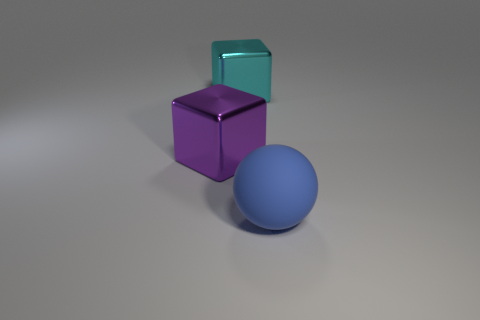Is there any other thing that has the same shape as the large matte object?
Keep it short and to the point. No. Is there a green thing that has the same material as the large ball?
Your answer should be very brief. No. There is a cube in front of the big object behind the big purple block; what is its material?
Ensure brevity in your answer.  Metal. How many blocks have the same color as the large ball?
Provide a succinct answer. 0. There is a cyan thing that is the same material as the large purple object; what size is it?
Provide a succinct answer. Large. What shape is the thing in front of the large purple shiny cube?
Offer a very short reply. Sphere. What is the size of the other metal thing that is the same shape as the purple metal object?
Offer a very short reply. Large. There is a large metallic thing behind the large metal block in front of the large cyan metal block; what number of rubber spheres are to the right of it?
Provide a succinct answer. 1. Is the number of cyan objects in front of the big purple object the same as the number of big rubber blocks?
Keep it short and to the point. Yes. What number of spheres are tiny yellow metallic objects or large blue rubber things?
Provide a short and direct response. 1. 